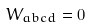<formula> <loc_0><loc_0><loc_500><loc_500>W _ { a b c d } = 0</formula> 